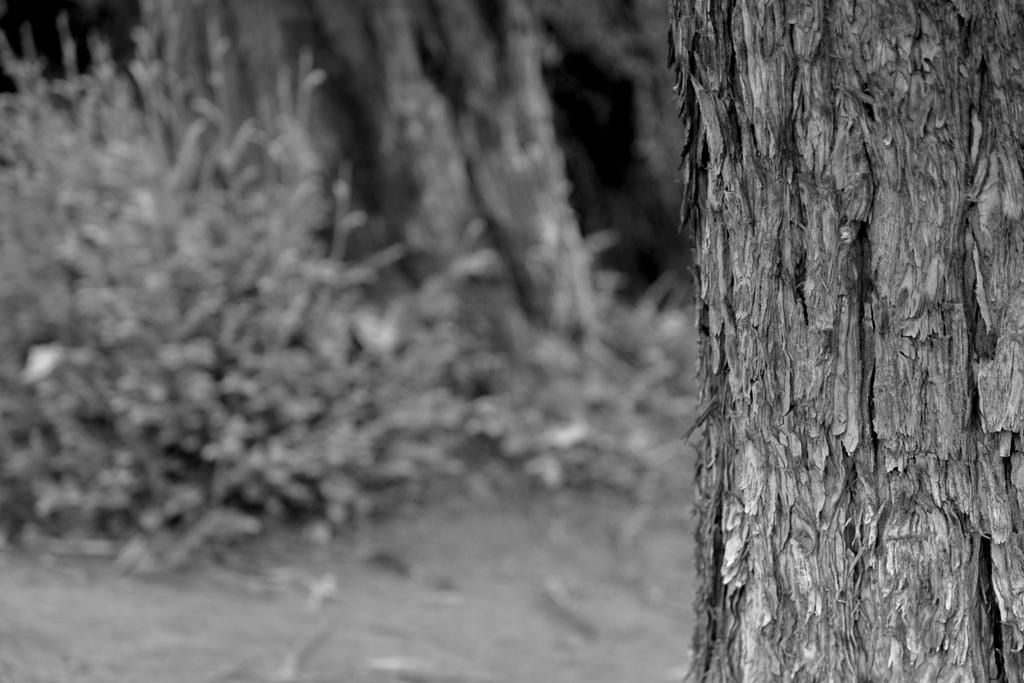What is the main subject in the foreground of the image? The main subject in the foreground of the image is the bark of a tree. What can be seen in the background of the image? In the background of the image, there are plants, dry leaves, and trees. Can you describe the vegetation in the image? The image contains both plants and trees, with dry leaves present in the background. What type of cracker is being used to clean the bark in the image? There is no cracker present in the image, nor is there any indication that the bark is being cleaned. 